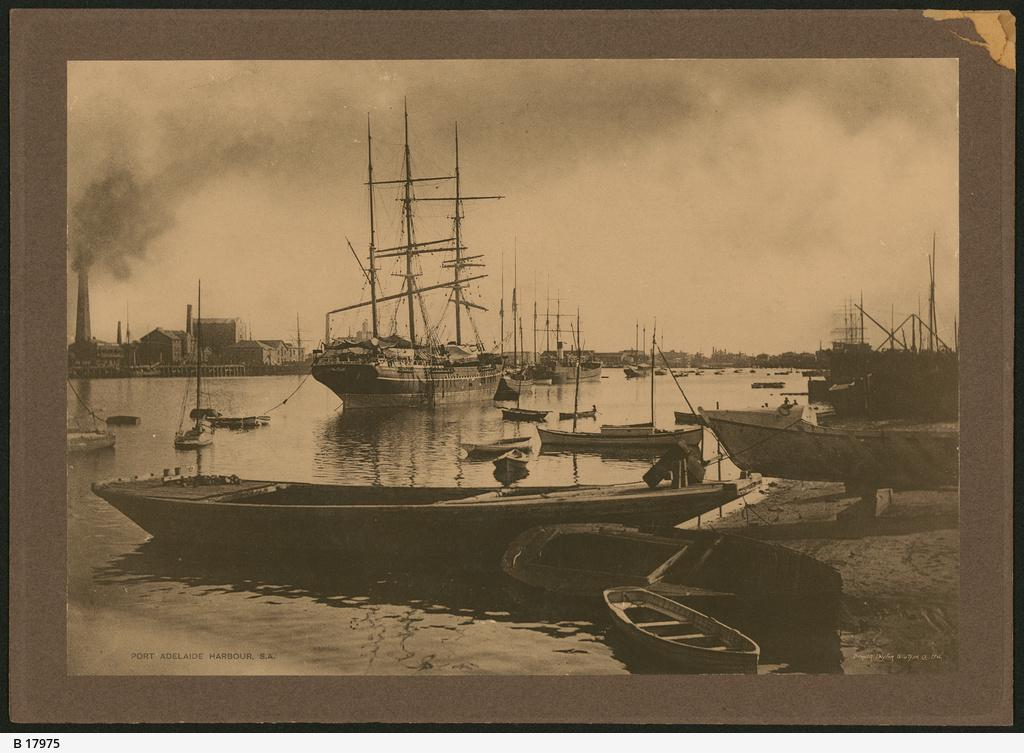What object is present in the image that contains a photo? There is a photo frame in the image. What is depicted in the photo inside the frame? The photo frame contains an image of boats floating on water. What can be seen in the background of the image? There are buildings and smoke visible in the background of the image. What part of the natural environment is visible in the image? The sky is visible in the background of the image. What type of property can be seen in the image? There is no property visible in the image; it features a photo frame with an image of boats floating on water, and the background includes buildings, smoke, and the sky. 